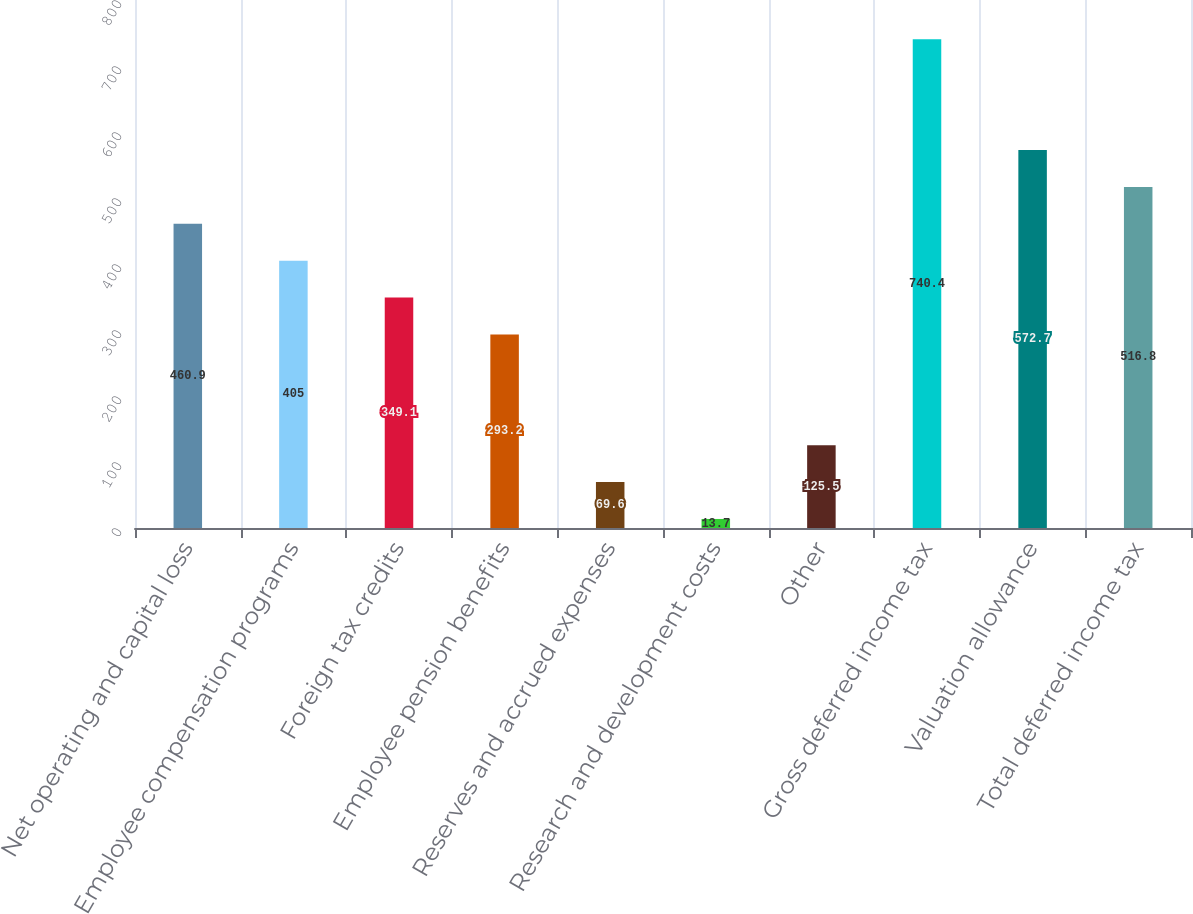<chart> <loc_0><loc_0><loc_500><loc_500><bar_chart><fcel>Net operating and capital loss<fcel>Employee compensation programs<fcel>Foreign tax credits<fcel>Employee pension benefits<fcel>Reserves and accrued expenses<fcel>Research and development costs<fcel>Other<fcel>Gross deferred income tax<fcel>Valuation allowance<fcel>Total deferred income tax<nl><fcel>460.9<fcel>405<fcel>349.1<fcel>293.2<fcel>69.6<fcel>13.7<fcel>125.5<fcel>740.4<fcel>572.7<fcel>516.8<nl></chart> 